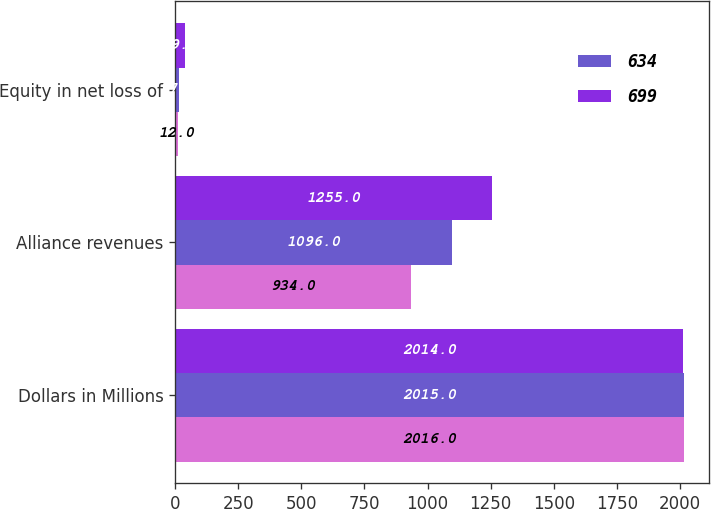Convert chart. <chart><loc_0><loc_0><loc_500><loc_500><stacked_bar_chart><ecel><fcel>Dollars in Millions<fcel>Alliance revenues<fcel>Equity in net loss of<nl><fcel>nan<fcel>2016<fcel>934<fcel>12<nl><fcel>634<fcel>2015<fcel>1096<fcel>17<nl><fcel>699<fcel>2014<fcel>1255<fcel>39<nl></chart> 